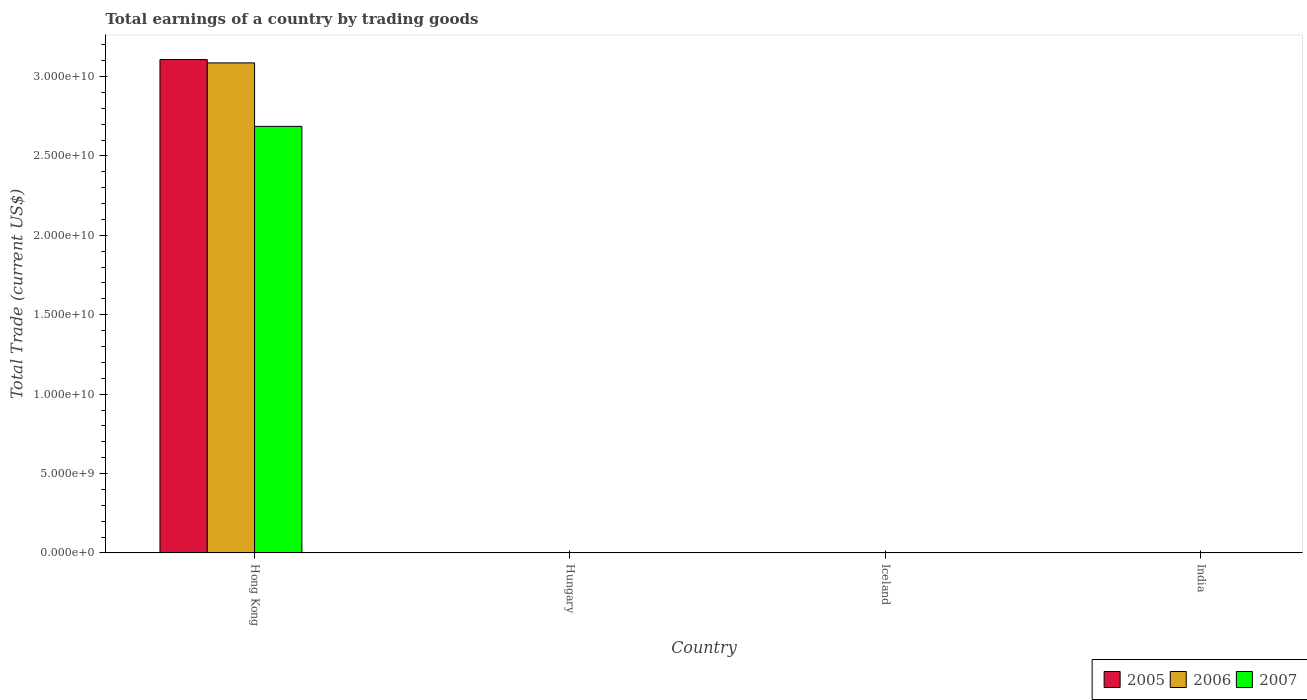How many different coloured bars are there?
Your answer should be compact. 3. What is the label of the 4th group of bars from the left?
Your answer should be very brief. India. In how many cases, is the number of bars for a given country not equal to the number of legend labels?
Your answer should be very brief. 3. What is the total earnings in 2007 in Hong Kong?
Ensure brevity in your answer.  2.69e+1. Across all countries, what is the maximum total earnings in 2007?
Offer a terse response. 2.69e+1. Across all countries, what is the minimum total earnings in 2007?
Provide a short and direct response. 0. In which country was the total earnings in 2006 maximum?
Provide a succinct answer. Hong Kong. What is the total total earnings in 2007 in the graph?
Provide a short and direct response. 2.69e+1. What is the difference between the total earnings in 2005 in India and the total earnings in 2007 in Hong Kong?
Your answer should be compact. -2.69e+1. What is the average total earnings in 2006 per country?
Ensure brevity in your answer.  7.71e+09. What is the difference between the total earnings of/in 2006 and total earnings of/in 2007 in Hong Kong?
Give a very brief answer. 4.00e+09. In how many countries, is the total earnings in 2006 greater than 26000000000 US$?
Your response must be concise. 1. What is the difference between the highest and the lowest total earnings in 2005?
Offer a terse response. 3.11e+1. How many countries are there in the graph?
Make the answer very short. 4. How many legend labels are there?
Your answer should be very brief. 3. What is the title of the graph?
Provide a short and direct response. Total earnings of a country by trading goods. Does "2014" appear as one of the legend labels in the graph?
Your answer should be compact. No. What is the label or title of the Y-axis?
Offer a terse response. Total Trade (current US$). What is the Total Trade (current US$) of 2005 in Hong Kong?
Offer a very short reply. 3.11e+1. What is the Total Trade (current US$) in 2006 in Hong Kong?
Offer a very short reply. 3.09e+1. What is the Total Trade (current US$) in 2007 in Hong Kong?
Offer a very short reply. 2.69e+1. What is the Total Trade (current US$) in 2006 in Iceland?
Your answer should be very brief. 0. What is the Total Trade (current US$) of 2005 in India?
Keep it short and to the point. 0. What is the Total Trade (current US$) in 2007 in India?
Provide a short and direct response. 0. Across all countries, what is the maximum Total Trade (current US$) in 2005?
Make the answer very short. 3.11e+1. Across all countries, what is the maximum Total Trade (current US$) in 2006?
Offer a terse response. 3.09e+1. Across all countries, what is the maximum Total Trade (current US$) of 2007?
Provide a succinct answer. 2.69e+1. Across all countries, what is the minimum Total Trade (current US$) in 2005?
Provide a short and direct response. 0. Across all countries, what is the minimum Total Trade (current US$) in 2007?
Offer a very short reply. 0. What is the total Total Trade (current US$) of 2005 in the graph?
Ensure brevity in your answer.  3.11e+1. What is the total Total Trade (current US$) of 2006 in the graph?
Keep it short and to the point. 3.09e+1. What is the total Total Trade (current US$) of 2007 in the graph?
Offer a very short reply. 2.69e+1. What is the average Total Trade (current US$) of 2005 per country?
Your response must be concise. 7.77e+09. What is the average Total Trade (current US$) of 2006 per country?
Provide a succinct answer. 7.71e+09. What is the average Total Trade (current US$) in 2007 per country?
Provide a short and direct response. 6.72e+09. What is the difference between the Total Trade (current US$) in 2005 and Total Trade (current US$) in 2006 in Hong Kong?
Provide a short and direct response. 2.11e+08. What is the difference between the Total Trade (current US$) of 2005 and Total Trade (current US$) of 2007 in Hong Kong?
Ensure brevity in your answer.  4.21e+09. What is the difference between the Total Trade (current US$) of 2006 and Total Trade (current US$) of 2007 in Hong Kong?
Your answer should be very brief. 4.00e+09. What is the difference between the highest and the lowest Total Trade (current US$) of 2005?
Provide a succinct answer. 3.11e+1. What is the difference between the highest and the lowest Total Trade (current US$) in 2006?
Offer a very short reply. 3.09e+1. What is the difference between the highest and the lowest Total Trade (current US$) of 2007?
Keep it short and to the point. 2.69e+1. 